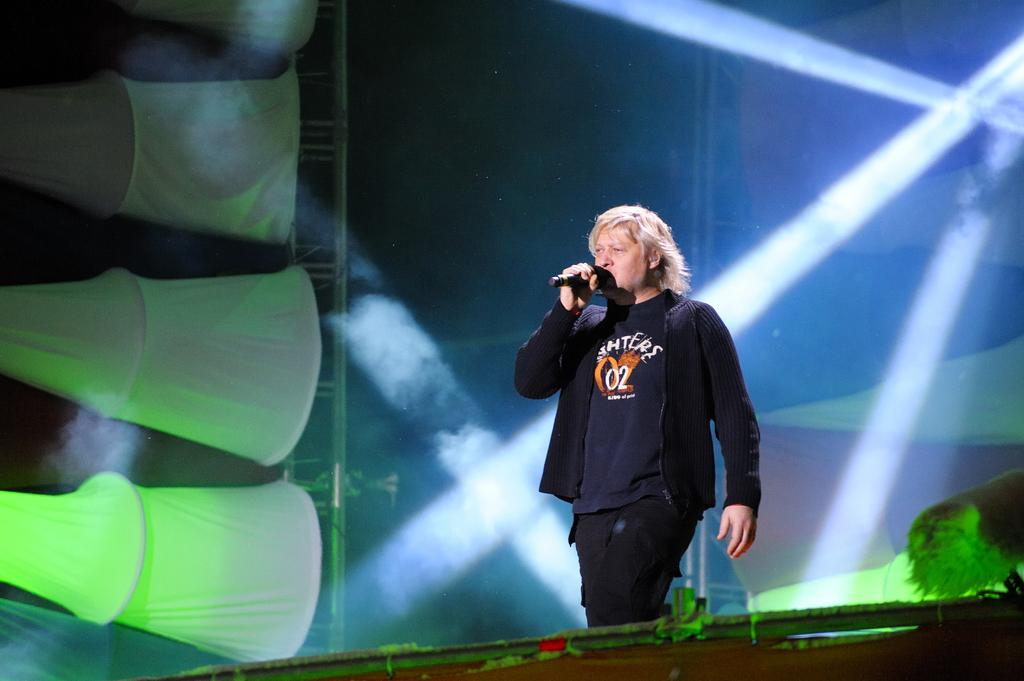What is the person in the image doing? The person is standing and holding a microphone. What can be seen in the background of the image? There is lighting truss and clothes visible in the background. What is the name of the pet in the image? There is no pet present in the image. 